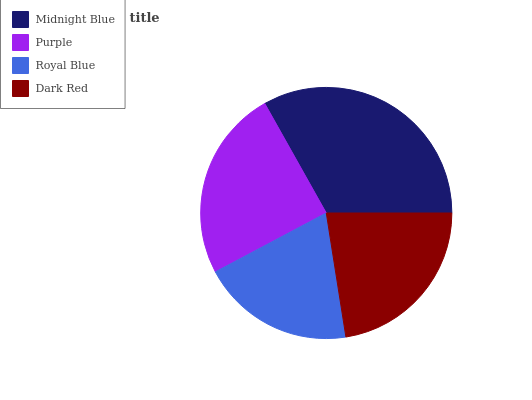Is Royal Blue the minimum?
Answer yes or no. Yes. Is Midnight Blue the maximum?
Answer yes or no. Yes. Is Purple the minimum?
Answer yes or no. No. Is Purple the maximum?
Answer yes or no. No. Is Midnight Blue greater than Purple?
Answer yes or no. Yes. Is Purple less than Midnight Blue?
Answer yes or no. Yes. Is Purple greater than Midnight Blue?
Answer yes or no. No. Is Midnight Blue less than Purple?
Answer yes or no. No. Is Purple the high median?
Answer yes or no. Yes. Is Dark Red the low median?
Answer yes or no. Yes. Is Royal Blue the high median?
Answer yes or no. No. Is Royal Blue the low median?
Answer yes or no. No. 